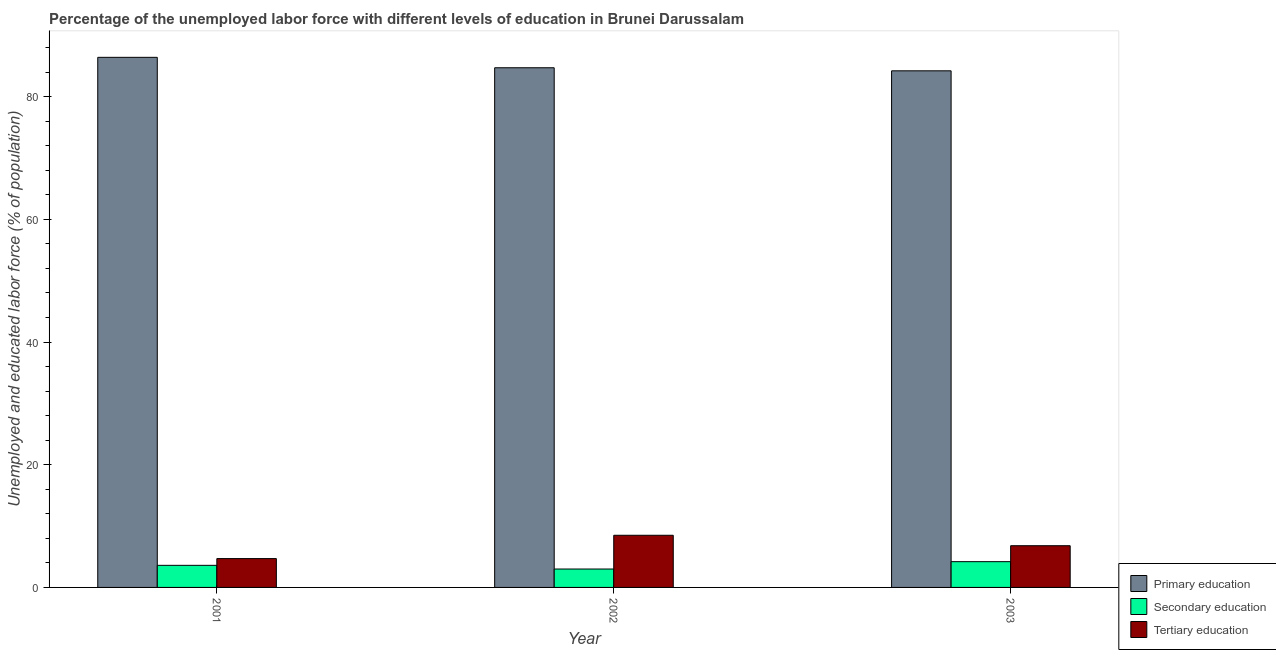How many groups of bars are there?
Make the answer very short. 3. Are the number of bars on each tick of the X-axis equal?
Your response must be concise. Yes. How many bars are there on the 2nd tick from the right?
Offer a very short reply. 3. In how many cases, is the number of bars for a given year not equal to the number of legend labels?
Your answer should be compact. 0. Across all years, what is the maximum percentage of labor force who received tertiary education?
Your answer should be very brief. 8.5. Across all years, what is the minimum percentage of labor force who received primary education?
Offer a very short reply. 84.2. In which year was the percentage of labor force who received tertiary education maximum?
Offer a very short reply. 2002. In which year was the percentage of labor force who received secondary education minimum?
Your answer should be compact. 2002. What is the total percentage of labor force who received tertiary education in the graph?
Offer a very short reply. 20. What is the difference between the percentage of labor force who received primary education in 2001 and that in 2002?
Your answer should be very brief. 1.7. What is the difference between the percentage of labor force who received primary education in 2003 and the percentage of labor force who received tertiary education in 2002?
Offer a terse response. -0.5. What is the average percentage of labor force who received secondary education per year?
Offer a terse response. 3.6. What is the ratio of the percentage of labor force who received primary education in 2001 to that in 2002?
Offer a very short reply. 1.02. What is the difference between the highest and the second highest percentage of labor force who received tertiary education?
Make the answer very short. 1.7. What is the difference between the highest and the lowest percentage of labor force who received secondary education?
Your response must be concise. 1.2. Is the sum of the percentage of labor force who received secondary education in 2001 and 2002 greater than the maximum percentage of labor force who received tertiary education across all years?
Your response must be concise. Yes. What does the 3rd bar from the left in 2003 represents?
Offer a terse response. Tertiary education. What does the 1st bar from the right in 2001 represents?
Your answer should be very brief. Tertiary education. Is it the case that in every year, the sum of the percentage of labor force who received primary education and percentage of labor force who received secondary education is greater than the percentage of labor force who received tertiary education?
Provide a succinct answer. Yes. How many bars are there?
Provide a short and direct response. 9. Are all the bars in the graph horizontal?
Provide a succinct answer. No. How many years are there in the graph?
Provide a short and direct response. 3. Are the values on the major ticks of Y-axis written in scientific E-notation?
Offer a very short reply. No. Where does the legend appear in the graph?
Make the answer very short. Bottom right. What is the title of the graph?
Your answer should be very brief. Percentage of the unemployed labor force with different levels of education in Brunei Darussalam. What is the label or title of the X-axis?
Offer a terse response. Year. What is the label or title of the Y-axis?
Provide a succinct answer. Unemployed and educated labor force (% of population). What is the Unemployed and educated labor force (% of population) in Primary education in 2001?
Your answer should be compact. 86.4. What is the Unemployed and educated labor force (% of population) in Secondary education in 2001?
Offer a terse response. 3.6. What is the Unemployed and educated labor force (% of population) in Tertiary education in 2001?
Ensure brevity in your answer.  4.7. What is the Unemployed and educated labor force (% of population) of Primary education in 2002?
Provide a short and direct response. 84.7. What is the Unemployed and educated labor force (% of population) of Secondary education in 2002?
Your answer should be compact. 3. What is the Unemployed and educated labor force (% of population) of Tertiary education in 2002?
Provide a succinct answer. 8.5. What is the Unemployed and educated labor force (% of population) of Primary education in 2003?
Provide a short and direct response. 84.2. What is the Unemployed and educated labor force (% of population) in Secondary education in 2003?
Provide a succinct answer. 4.2. What is the Unemployed and educated labor force (% of population) in Tertiary education in 2003?
Provide a succinct answer. 6.8. Across all years, what is the maximum Unemployed and educated labor force (% of population) in Primary education?
Your answer should be very brief. 86.4. Across all years, what is the maximum Unemployed and educated labor force (% of population) of Secondary education?
Keep it short and to the point. 4.2. Across all years, what is the minimum Unemployed and educated labor force (% of population) in Primary education?
Your answer should be very brief. 84.2. Across all years, what is the minimum Unemployed and educated labor force (% of population) of Tertiary education?
Your answer should be compact. 4.7. What is the total Unemployed and educated labor force (% of population) of Primary education in the graph?
Keep it short and to the point. 255.3. What is the difference between the Unemployed and educated labor force (% of population) of Secondary education in 2001 and that in 2002?
Make the answer very short. 0.6. What is the difference between the Unemployed and educated labor force (% of population) in Tertiary education in 2001 and that in 2002?
Give a very brief answer. -3.8. What is the difference between the Unemployed and educated labor force (% of population) of Primary education in 2001 and that in 2003?
Your answer should be compact. 2.2. What is the difference between the Unemployed and educated labor force (% of population) in Tertiary education in 2001 and that in 2003?
Your answer should be compact. -2.1. What is the difference between the Unemployed and educated labor force (% of population) in Secondary education in 2002 and that in 2003?
Your response must be concise. -1.2. What is the difference between the Unemployed and educated labor force (% of population) in Tertiary education in 2002 and that in 2003?
Give a very brief answer. 1.7. What is the difference between the Unemployed and educated labor force (% of population) in Primary education in 2001 and the Unemployed and educated labor force (% of population) in Secondary education in 2002?
Your answer should be compact. 83.4. What is the difference between the Unemployed and educated labor force (% of population) in Primary education in 2001 and the Unemployed and educated labor force (% of population) in Tertiary education in 2002?
Provide a short and direct response. 77.9. What is the difference between the Unemployed and educated labor force (% of population) in Primary education in 2001 and the Unemployed and educated labor force (% of population) in Secondary education in 2003?
Offer a very short reply. 82.2. What is the difference between the Unemployed and educated labor force (% of population) in Primary education in 2001 and the Unemployed and educated labor force (% of population) in Tertiary education in 2003?
Your response must be concise. 79.6. What is the difference between the Unemployed and educated labor force (% of population) of Secondary education in 2001 and the Unemployed and educated labor force (% of population) of Tertiary education in 2003?
Provide a short and direct response. -3.2. What is the difference between the Unemployed and educated labor force (% of population) of Primary education in 2002 and the Unemployed and educated labor force (% of population) of Secondary education in 2003?
Your answer should be very brief. 80.5. What is the difference between the Unemployed and educated labor force (% of population) of Primary education in 2002 and the Unemployed and educated labor force (% of population) of Tertiary education in 2003?
Ensure brevity in your answer.  77.9. What is the average Unemployed and educated labor force (% of population) of Primary education per year?
Provide a short and direct response. 85.1. What is the average Unemployed and educated labor force (% of population) in Secondary education per year?
Ensure brevity in your answer.  3.6. What is the average Unemployed and educated labor force (% of population) of Tertiary education per year?
Provide a succinct answer. 6.67. In the year 2001, what is the difference between the Unemployed and educated labor force (% of population) of Primary education and Unemployed and educated labor force (% of population) of Secondary education?
Give a very brief answer. 82.8. In the year 2001, what is the difference between the Unemployed and educated labor force (% of population) in Primary education and Unemployed and educated labor force (% of population) in Tertiary education?
Ensure brevity in your answer.  81.7. In the year 2001, what is the difference between the Unemployed and educated labor force (% of population) of Secondary education and Unemployed and educated labor force (% of population) of Tertiary education?
Your answer should be compact. -1.1. In the year 2002, what is the difference between the Unemployed and educated labor force (% of population) of Primary education and Unemployed and educated labor force (% of population) of Secondary education?
Your answer should be very brief. 81.7. In the year 2002, what is the difference between the Unemployed and educated labor force (% of population) in Primary education and Unemployed and educated labor force (% of population) in Tertiary education?
Your response must be concise. 76.2. In the year 2003, what is the difference between the Unemployed and educated labor force (% of population) in Primary education and Unemployed and educated labor force (% of population) in Tertiary education?
Offer a very short reply. 77.4. What is the ratio of the Unemployed and educated labor force (% of population) in Primary education in 2001 to that in 2002?
Your answer should be compact. 1.02. What is the ratio of the Unemployed and educated labor force (% of population) in Tertiary education in 2001 to that in 2002?
Provide a succinct answer. 0.55. What is the ratio of the Unemployed and educated labor force (% of population) in Primary education in 2001 to that in 2003?
Your response must be concise. 1.03. What is the ratio of the Unemployed and educated labor force (% of population) of Tertiary education in 2001 to that in 2003?
Offer a very short reply. 0.69. What is the ratio of the Unemployed and educated labor force (% of population) of Primary education in 2002 to that in 2003?
Offer a terse response. 1.01. What is the ratio of the Unemployed and educated labor force (% of population) of Secondary education in 2002 to that in 2003?
Your answer should be compact. 0.71. What is the ratio of the Unemployed and educated labor force (% of population) in Tertiary education in 2002 to that in 2003?
Give a very brief answer. 1.25. What is the difference between the highest and the second highest Unemployed and educated labor force (% of population) in Primary education?
Make the answer very short. 1.7. What is the difference between the highest and the second highest Unemployed and educated labor force (% of population) in Tertiary education?
Provide a short and direct response. 1.7. What is the difference between the highest and the lowest Unemployed and educated labor force (% of population) of Primary education?
Your answer should be compact. 2.2. 